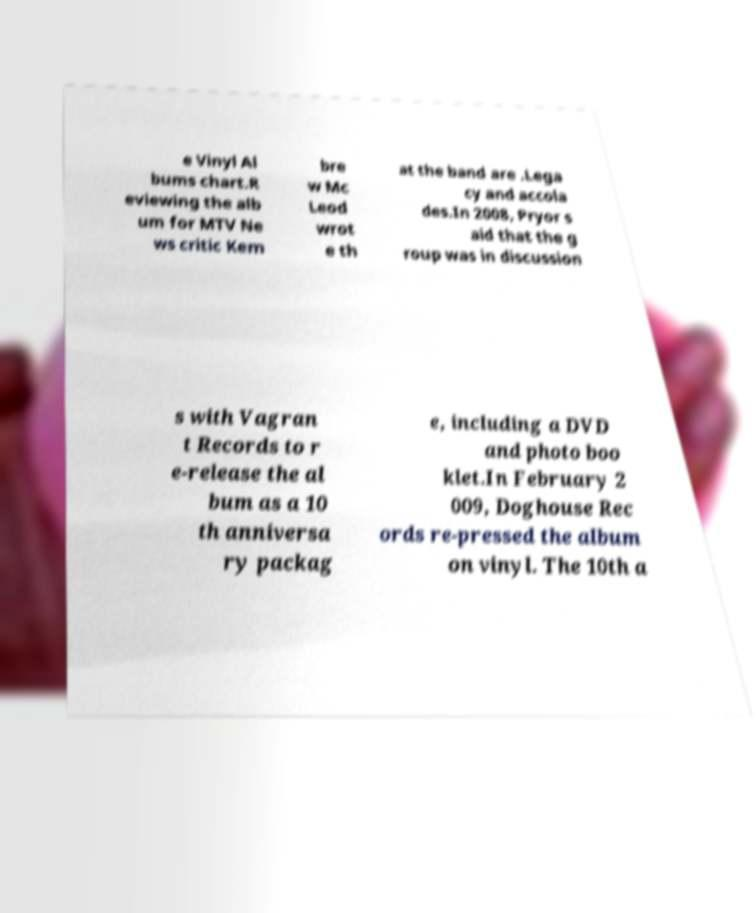Please identify and transcribe the text found in this image. e Vinyl Al bums chart.R eviewing the alb um for MTV Ne ws critic Kem bre w Mc Leod wrot e th at the band are .Lega cy and accola des.In 2008, Pryor s aid that the g roup was in discussion s with Vagran t Records to r e-release the al bum as a 10 th anniversa ry packag e, including a DVD and photo boo klet.In February 2 009, Doghouse Rec ords re-pressed the album on vinyl. The 10th a 